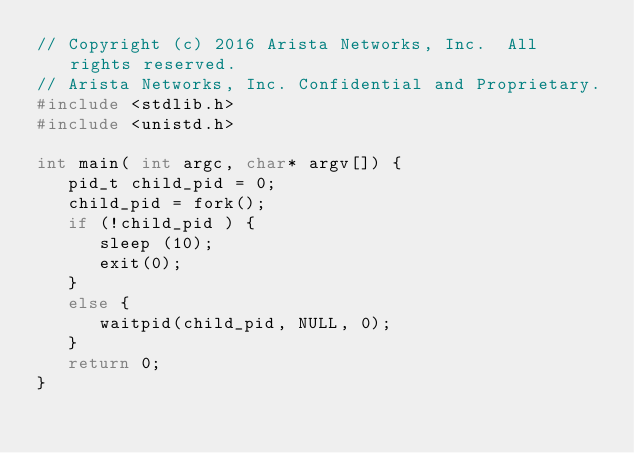<code> <loc_0><loc_0><loc_500><loc_500><_C_>// Copyright (c) 2016 Arista Networks, Inc.  All rights reserved.
// Arista Networks, Inc. Confidential and Proprietary.
#include <stdlib.h>
#include <unistd.h>

int main( int argc, char* argv[]) {
   pid_t child_pid = 0;
   child_pid = fork();
   if (!child_pid ) {
      sleep (10);
      exit(0);
   }
   else {
      waitpid(child_pid, NULL, 0);
   }
   return 0;
}
</code> 